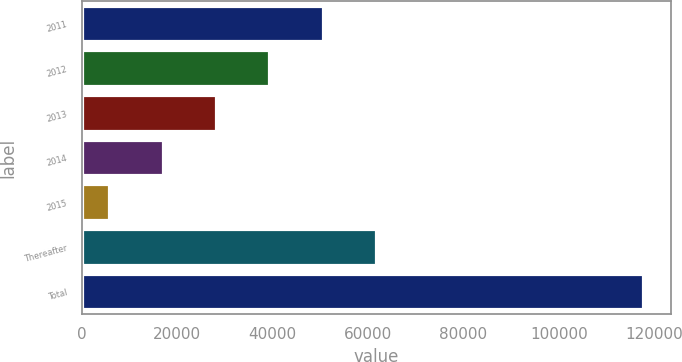<chart> <loc_0><loc_0><loc_500><loc_500><bar_chart><fcel>2011<fcel>2012<fcel>2013<fcel>2014<fcel>2015<fcel>Thereafter<fcel>Total<nl><fcel>50540.4<fcel>39361.3<fcel>28182.2<fcel>17003.1<fcel>5824<fcel>61719.5<fcel>117615<nl></chart> 